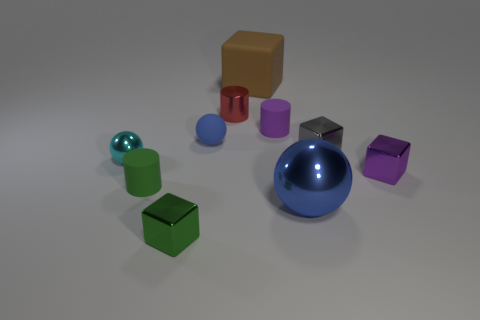Subtract all blue cubes. How many blue balls are left? 2 Subtract all purple cubes. How many cubes are left? 3 Subtract all matte cylinders. How many cylinders are left? 1 Subtract all cyan cubes. Subtract all purple cylinders. How many cubes are left? 4 Subtract all spheres. How many objects are left? 7 Subtract 0 red spheres. How many objects are left? 10 Subtract all small spheres. Subtract all big blue metallic balls. How many objects are left? 7 Add 5 small metal cubes. How many small metal cubes are left? 8 Add 4 rubber cylinders. How many rubber cylinders exist? 6 